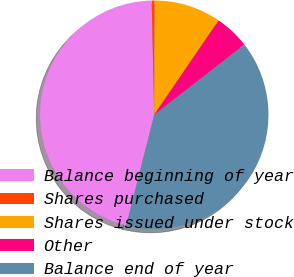Convert chart to OTSL. <chart><loc_0><loc_0><loc_500><loc_500><pie_chart><fcel>Balance beginning of year<fcel>Shares purchased<fcel>Shares issued under stock<fcel>Other<fcel>Balance end of year<nl><fcel>45.7%<fcel>0.42%<fcel>9.47%<fcel>4.94%<fcel>39.46%<nl></chart> 